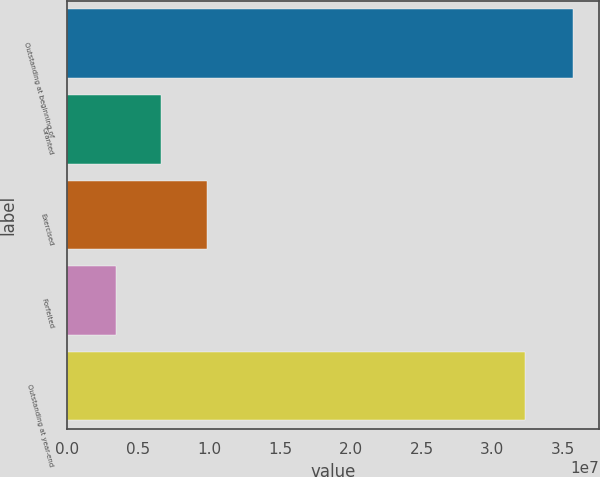Convert chart to OTSL. <chart><loc_0><loc_0><loc_500><loc_500><bar_chart><fcel>Outstanding at beginning of<fcel>Granted<fcel>Exercised<fcel>Forfeited<fcel>Outstanding at year-end<nl><fcel>3.57188e+07<fcel>6.62811e+06<fcel>9.86041e+06<fcel>3.39581e+06<fcel>3.23013e+07<nl></chart> 